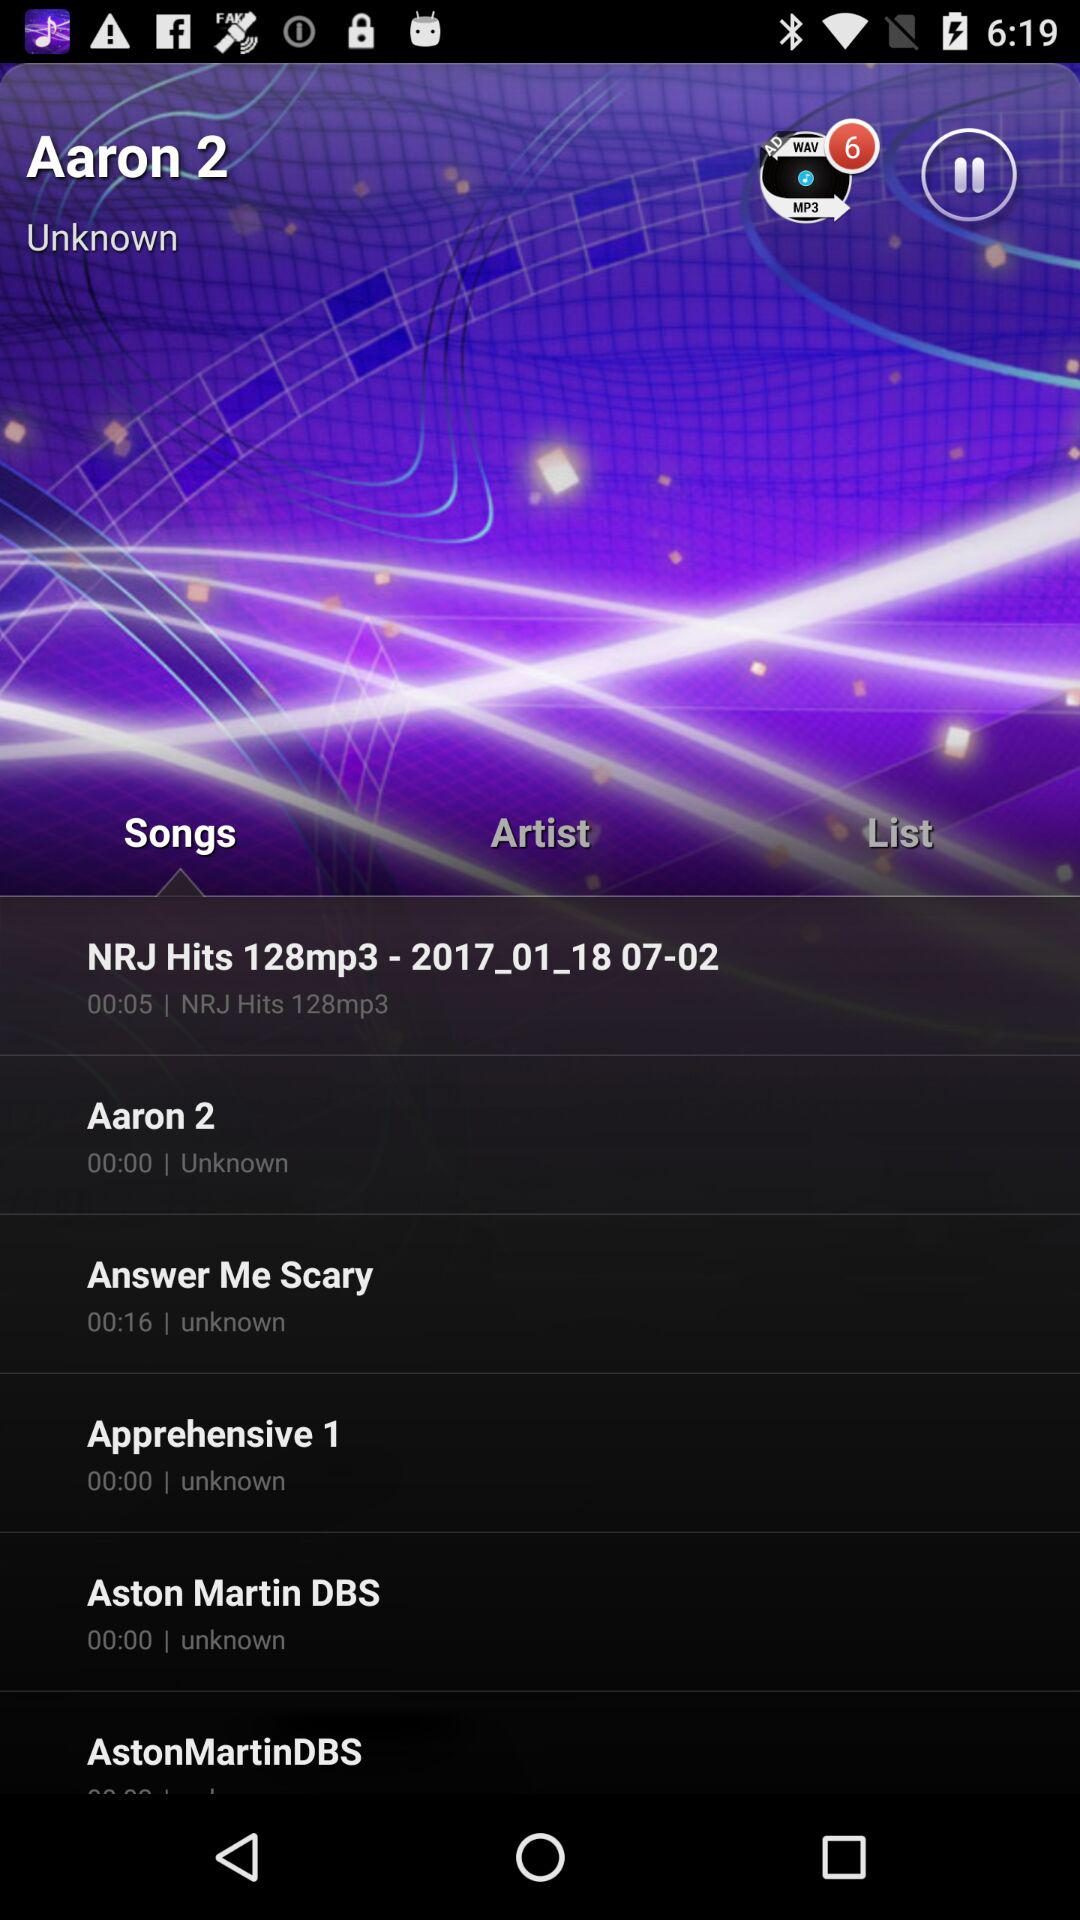How many total songs are there? There are total 6 songs. 